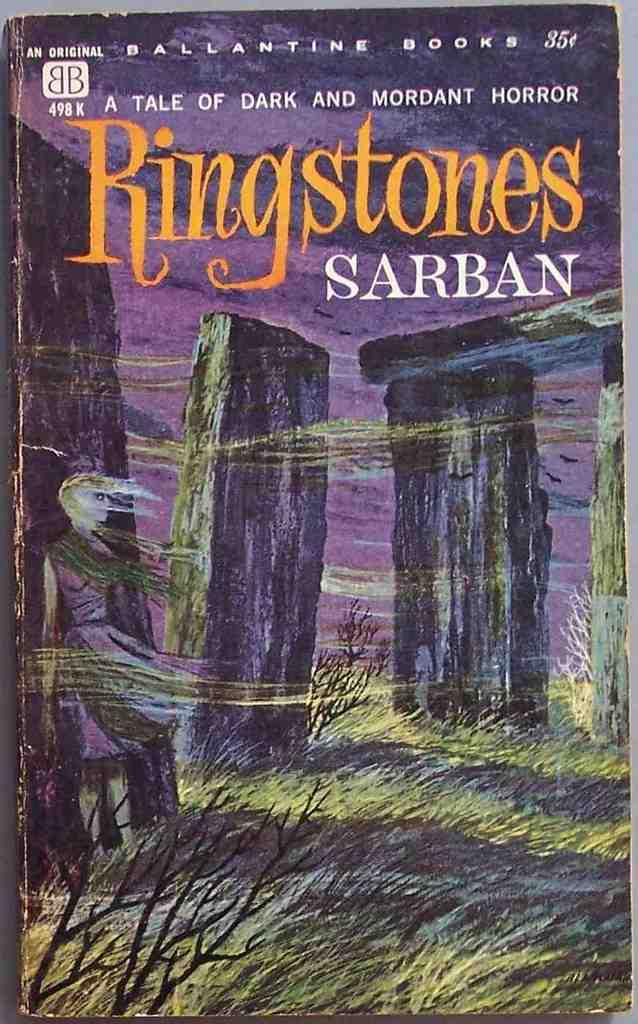<image>
Write a terse but informative summary of the picture. a paper back by Ballantine Books for ringstones sarban 